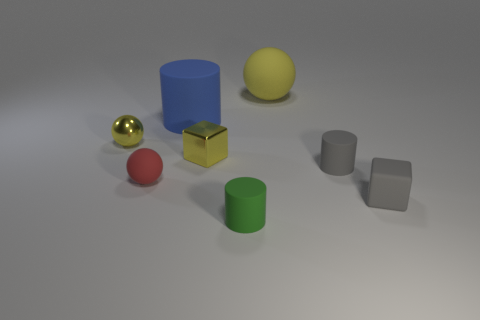The matte ball that is in front of the tiny metal ball is what color?
Offer a terse response. Red. What material is the cylinder that is behind the small gray block and in front of the blue cylinder?
Provide a succinct answer. Rubber. What number of tiny gray matte things are behind the block that is to the left of the green rubber thing?
Your answer should be very brief. 0. What is the shape of the red object?
Provide a succinct answer. Sphere. The green object that is made of the same material as the large ball is what shape?
Your answer should be compact. Cylinder. Do the small metallic object that is on the right side of the small metal ball and the big yellow rubber thing have the same shape?
Provide a short and direct response. No. What shape is the large matte thing on the right side of the small green rubber thing?
Make the answer very short. Sphere. The small matte thing that is the same color as the small rubber block is what shape?
Your answer should be very brief. Cylinder. How many gray rubber cylinders have the same size as the red ball?
Provide a succinct answer. 1. What is the color of the tiny metallic cube?
Make the answer very short. Yellow. 